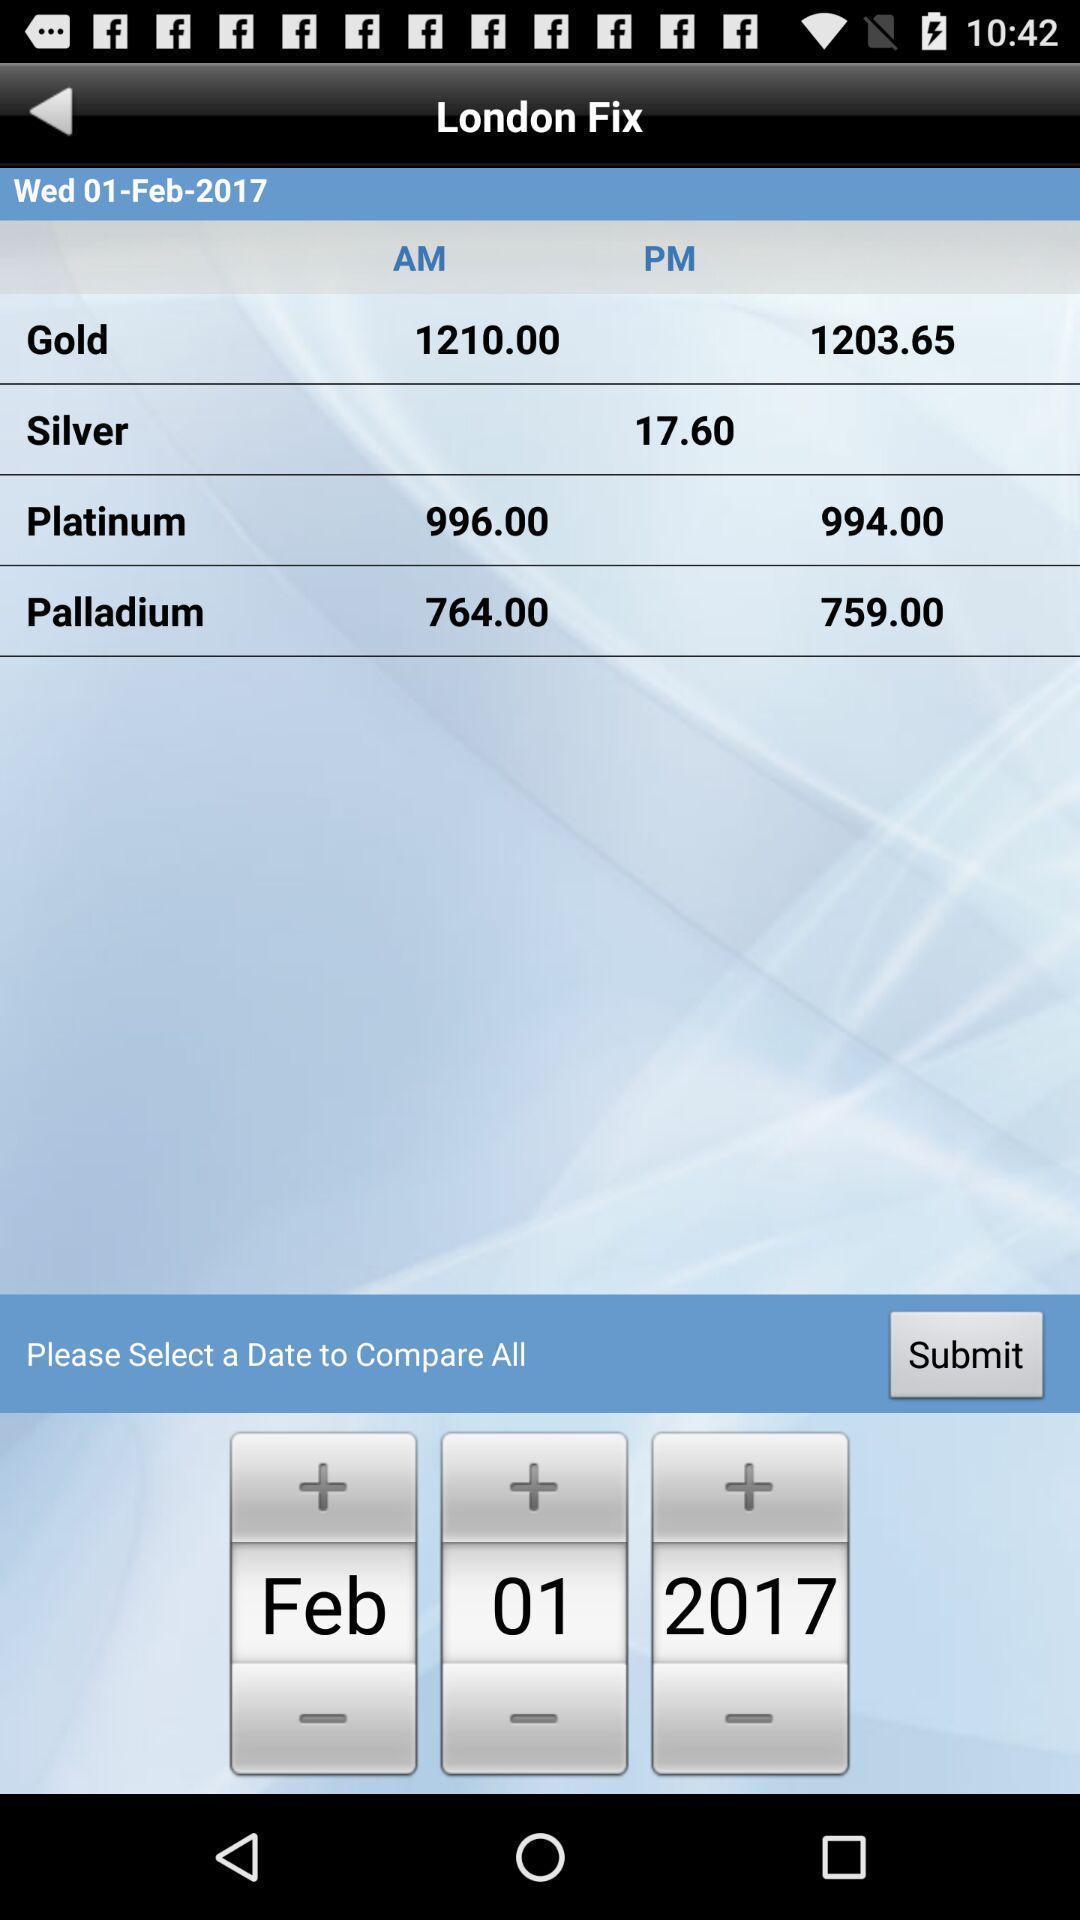Please provide a description for this image. Page displaying details of metals and option to compare all. 